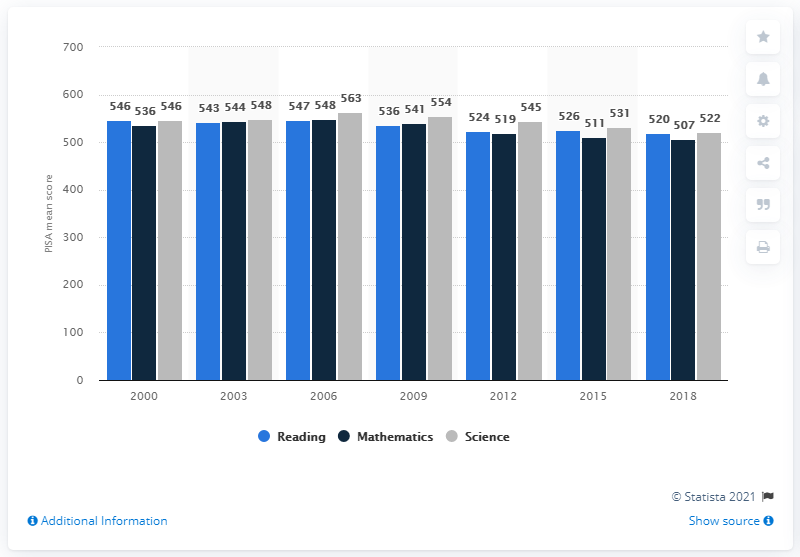Specify some key components in this picture. In 2018, Finnish students performed significantly better than the OECD average in reading, mathematics, and science knowledge. The first PISA test was conducted in 2000. 